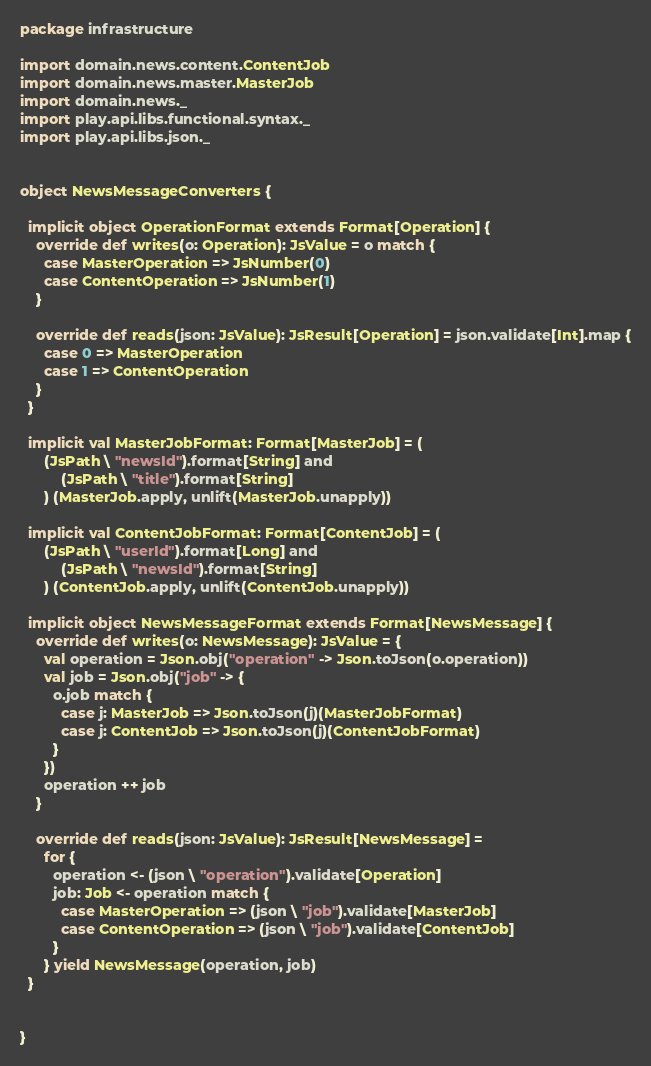<code> <loc_0><loc_0><loc_500><loc_500><_Scala_>package infrastructure

import domain.news.content.ContentJob
import domain.news.master.MasterJob
import domain.news._
import play.api.libs.functional.syntax._
import play.api.libs.json._


object NewsMessageConverters {

  implicit object OperationFormat extends Format[Operation] {
    override def writes(o: Operation): JsValue = o match {
      case MasterOperation => JsNumber(0)
      case ContentOperation => JsNumber(1)
    }

    override def reads(json: JsValue): JsResult[Operation] = json.validate[Int].map {
      case 0 => MasterOperation
      case 1 => ContentOperation
    }
  }

  implicit val MasterJobFormat: Format[MasterJob] = (
      (JsPath \ "newsId").format[String] and
          (JsPath \ "title").format[String]
      ) (MasterJob.apply, unlift(MasterJob.unapply))

  implicit val ContentJobFormat: Format[ContentJob] = (
      (JsPath \ "userId").format[Long] and
          (JsPath \ "newsId").format[String]
      ) (ContentJob.apply, unlift(ContentJob.unapply))

  implicit object NewsMessageFormat extends Format[NewsMessage] {
    override def writes(o: NewsMessage): JsValue = {
      val operation = Json.obj("operation" -> Json.toJson(o.operation))
      val job = Json.obj("job" -> {
        o.job match {
          case j: MasterJob => Json.toJson(j)(MasterJobFormat)
          case j: ContentJob => Json.toJson(j)(ContentJobFormat)
        }
      })
      operation ++ job
    }

    override def reads(json: JsValue): JsResult[NewsMessage] =
      for {
        operation <- (json \ "operation").validate[Operation]
        job: Job <- operation match {
          case MasterOperation => (json \ "job").validate[MasterJob]
          case ContentOperation => (json \ "job").validate[ContentJob]
        }
      } yield NewsMessage(operation, job)
  }


}
</code> 